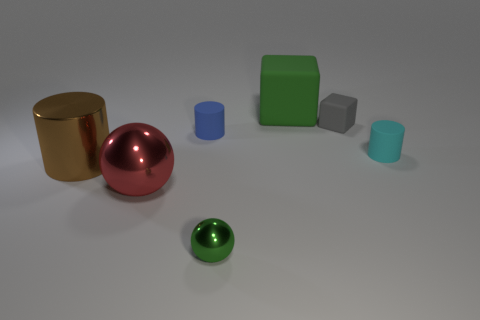There is a rubber block behind the gray matte thing; does it have the same color as the small metal ball?
Your response must be concise. Yes. Is the material of the green object that is behind the large brown cylinder the same as the ball that is on the left side of the tiny metallic object?
Provide a succinct answer. No. There is a ball in front of the red metallic object; is its size the same as the green matte cube?
Offer a terse response. No. Do the big rubber cube and the ball that is to the left of the green ball have the same color?
Your answer should be compact. No. What shape is the rubber object that is the same color as the small sphere?
Offer a terse response. Cube. The red thing has what shape?
Offer a very short reply. Sphere. Does the large shiny sphere have the same color as the small cube?
Offer a very short reply. No. How many things are big things behind the brown shiny cylinder or tiny gray matte things?
Your response must be concise. 2. What size is the blue cylinder that is the same material as the gray object?
Give a very brief answer. Small. Are there more small blue rubber things on the left side of the green cube than small spheres?
Offer a terse response. No. 